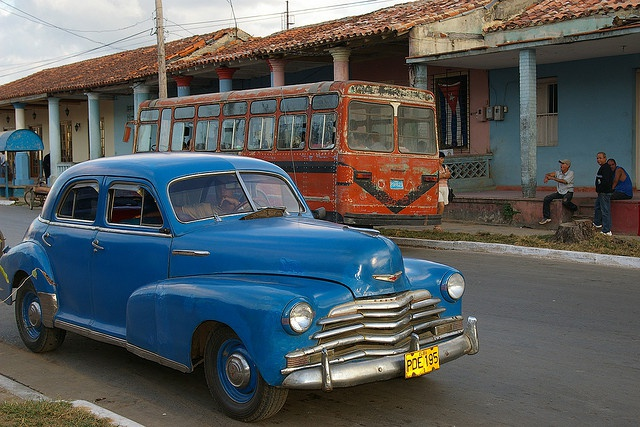Describe the objects in this image and their specific colors. I can see car in lightgray, blue, navy, black, and gray tones, bus in lightgray, gray, black, maroon, and brown tones, people in lightgray, gray, black, and darkblue tones, people in lightgray, black, gray, and maroon tones, and people in lightgray, black, maroon, gray, and darkblue tones in this image. 